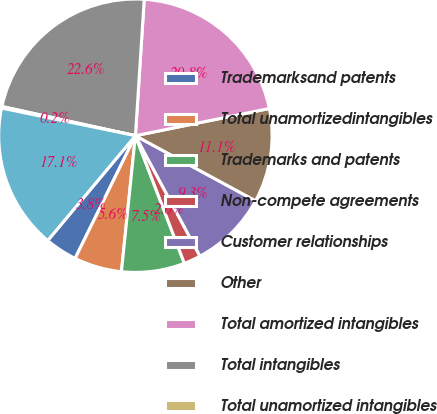Convert chart to OTSL. <chart><loc_0><loc_0><loc_500><loc_500><pie_chart><fcel>Trademarksand patents<fcel>Total unamortizedintangibles<fcel>Trademarks and patents<fcel>Non-compete agreements<fcel>Customer relationships<fcel>Other<fcel>Total amortized intangibles<fcel>Total intangibles<fcel>Total unamortized intangibles<fcel>Total amortizedintangibles<nl><fcel>3.82%<fcel>5.64%<fcel>7.46%<fcel>2.0%<fcel>9.27%<fcel>11.09%<fcel>20.78%<fcel>22.6%<fcel>0.19%<fcel>17.15%<nl></chart> 